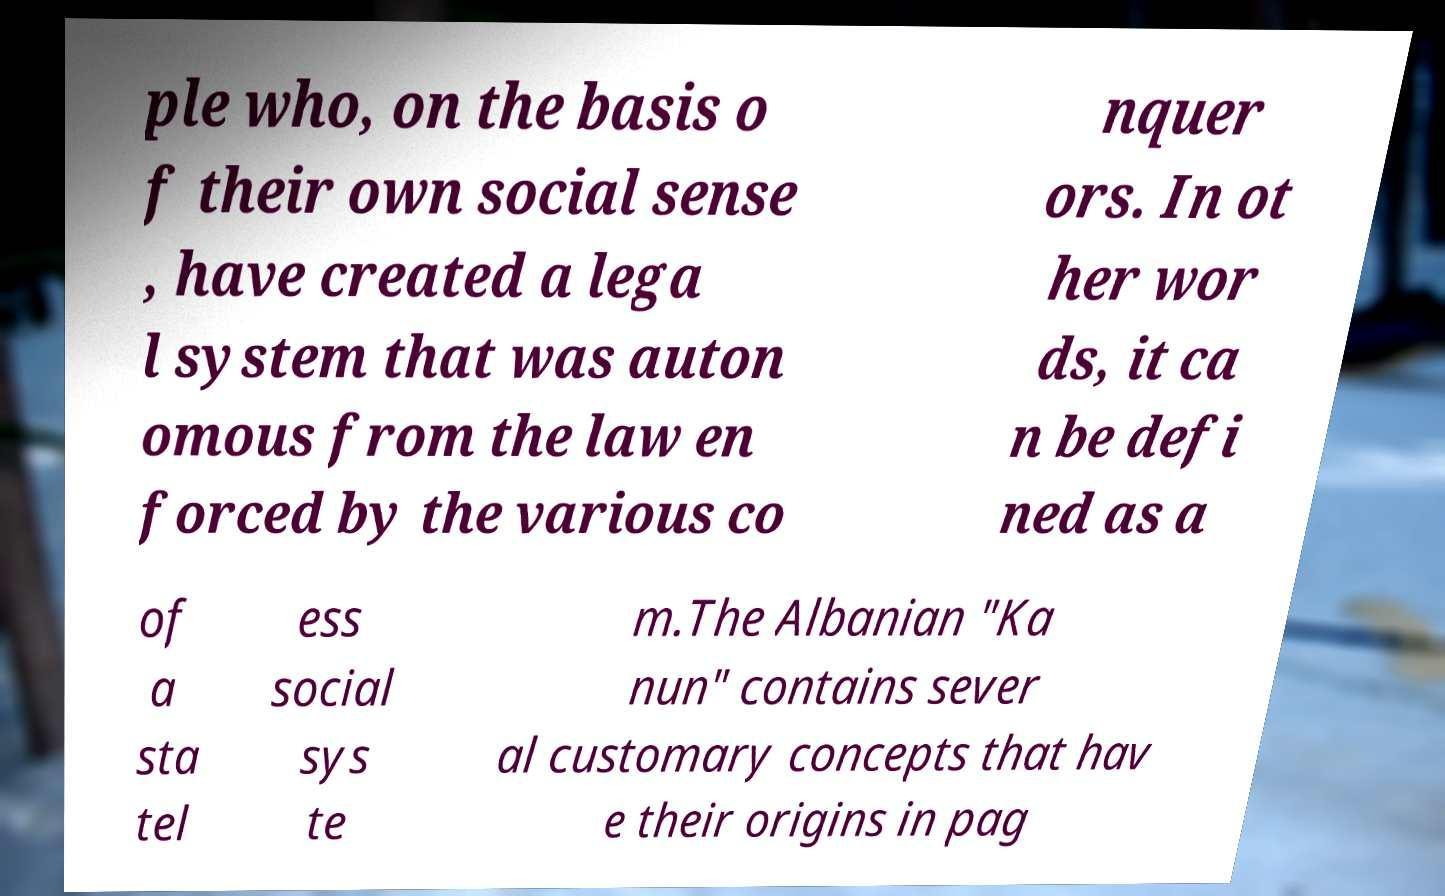Could you assist in decoding the text presented in this image and type it out clearly? ple who, on the basis o f their own social sense , have created a lega l system that was auton omous from the law en forced by the various co nquer ors. In ot her wor ds, it ca n be defi ned as a of a sta tel ess social sys te m.The Albanian "Ka nun" contains sever al customary concepts that hav e their origins in pag 